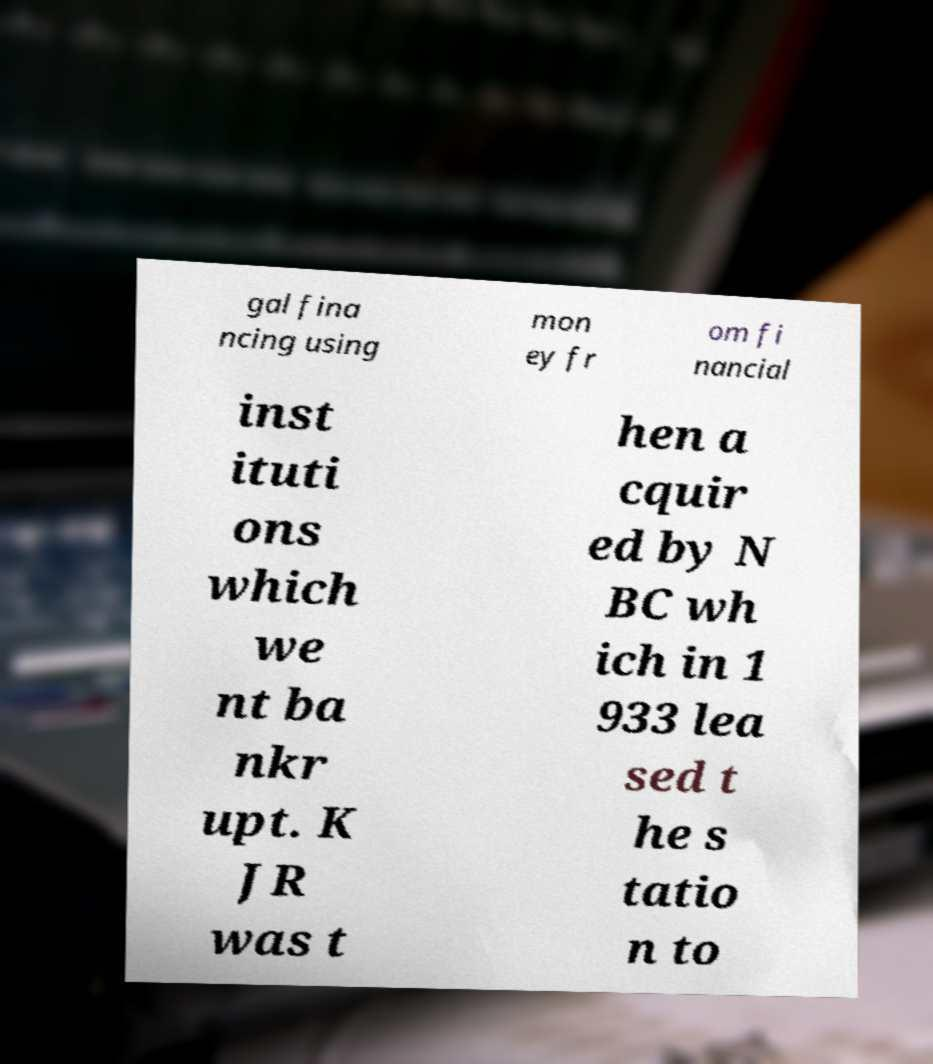I need the written content from this picture converted into text. Can you do that? gal fina ncing using mon ey fr om fi nancial inst ituti ons which we nt ba nkr upt. K JR was t hen a cquir ed by N BC wh ich in 1 933 lea sed t he s tatio n to 